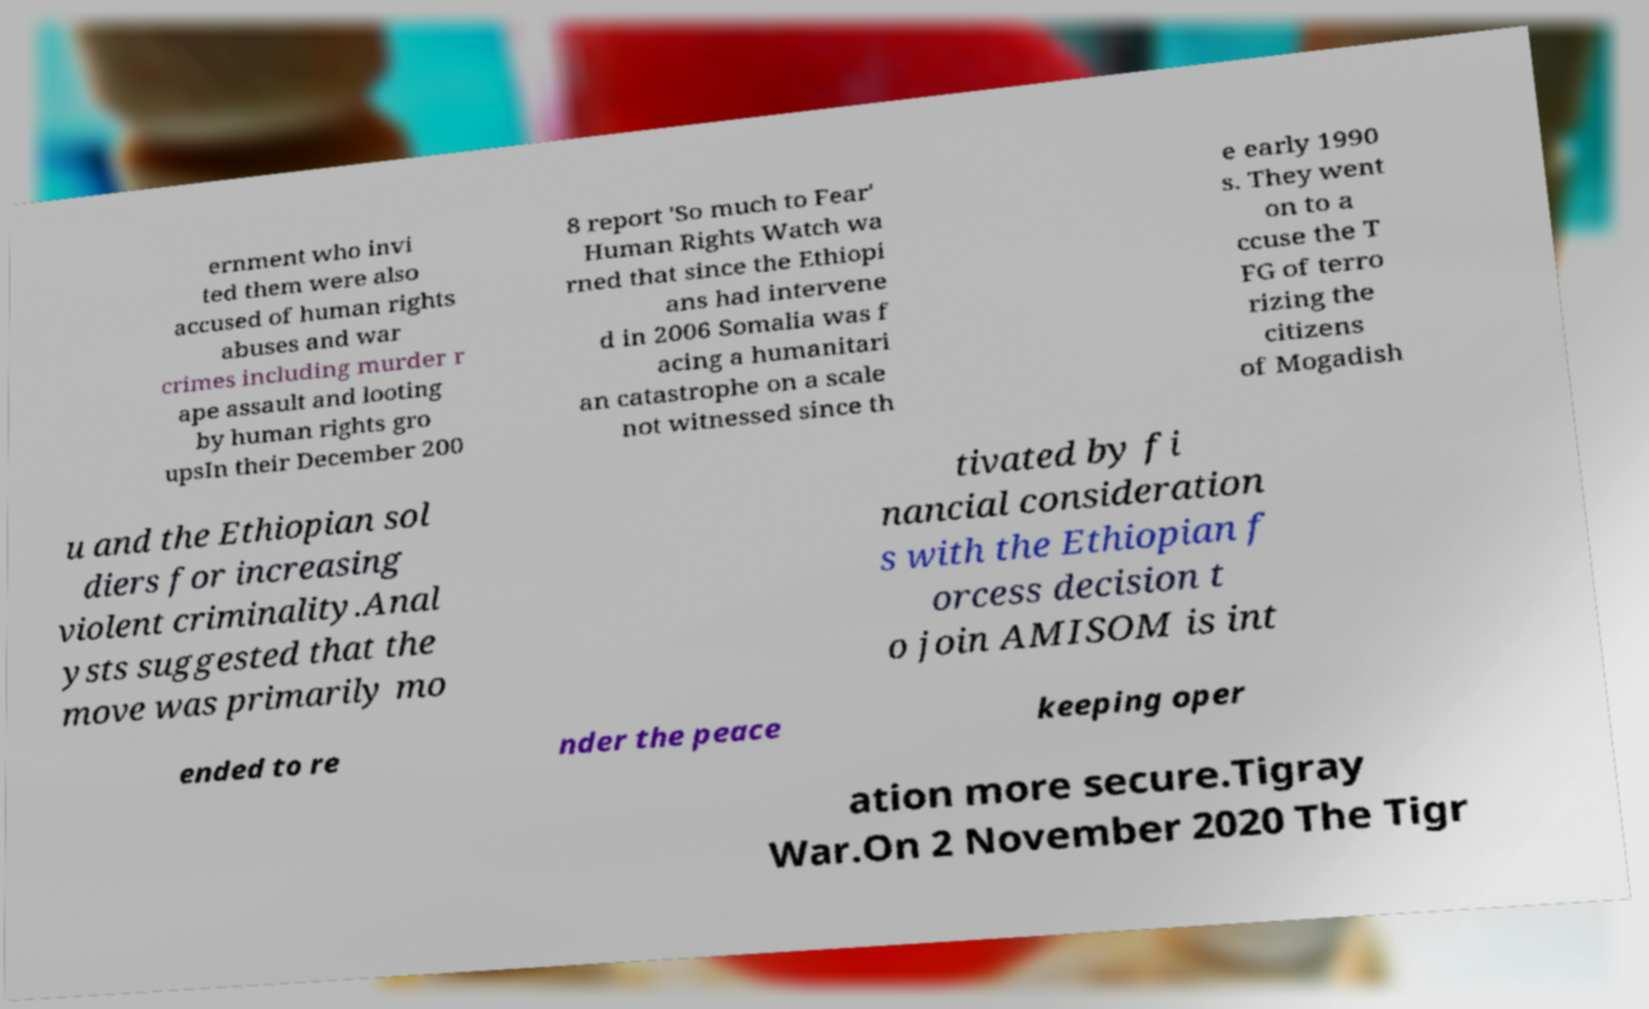For documentation purposes, I need the text within this image transcribed. Could you provide that? ernment who invi ted them were also accused of human rights abuses and war crimes including murder r ape assault and looting by human rights gro upsIn their December 200 8 report 'So much to Fear' Human Rights Watch wa rned that since the Ethiopi ans had intervene d in 2006 Somalia was f acing a humanitari an catastrophe on a scale not witnessed since th e early 1990 s. They went on to a ccuse the T FG of terro rizing the citizens of Mogadish u and the Ethiopian sol diers for increasing violent criminality.Anal ysts suggested that the move was primarily mo tivated by fi nancial consideration s with the Ethiopian f orcess decision t o join AMISOM is int ended to re nder the peace keeping oper ation more secure.Tigray War.On 2 November 2020 The Tigr 